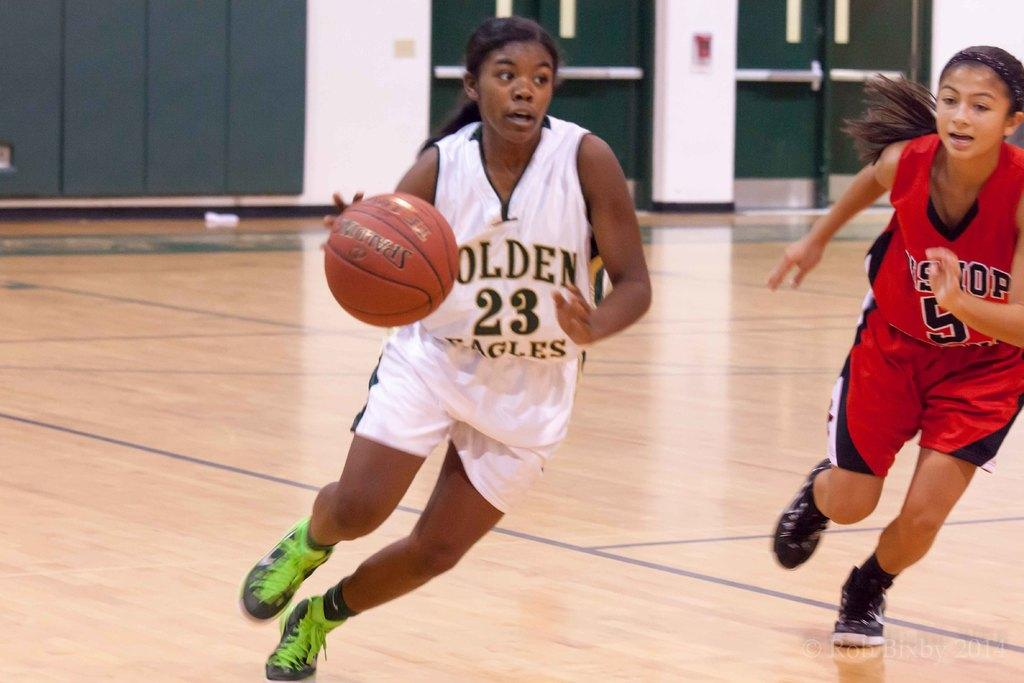<image>
Summarize the visual content of the image. A Golden Eagles basketball player is closely followed by a member of the opposing team. 